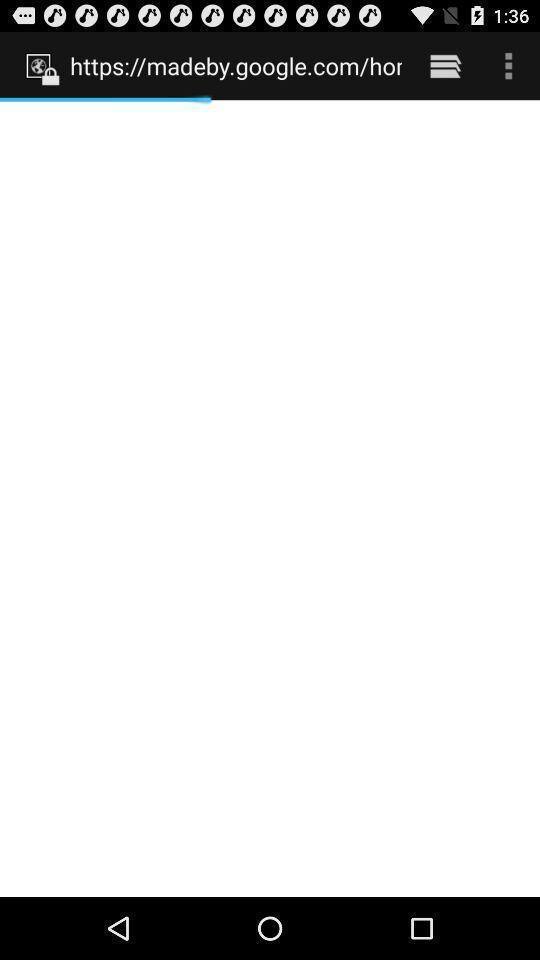Please provide a description for this image. Page displaying website loading. 